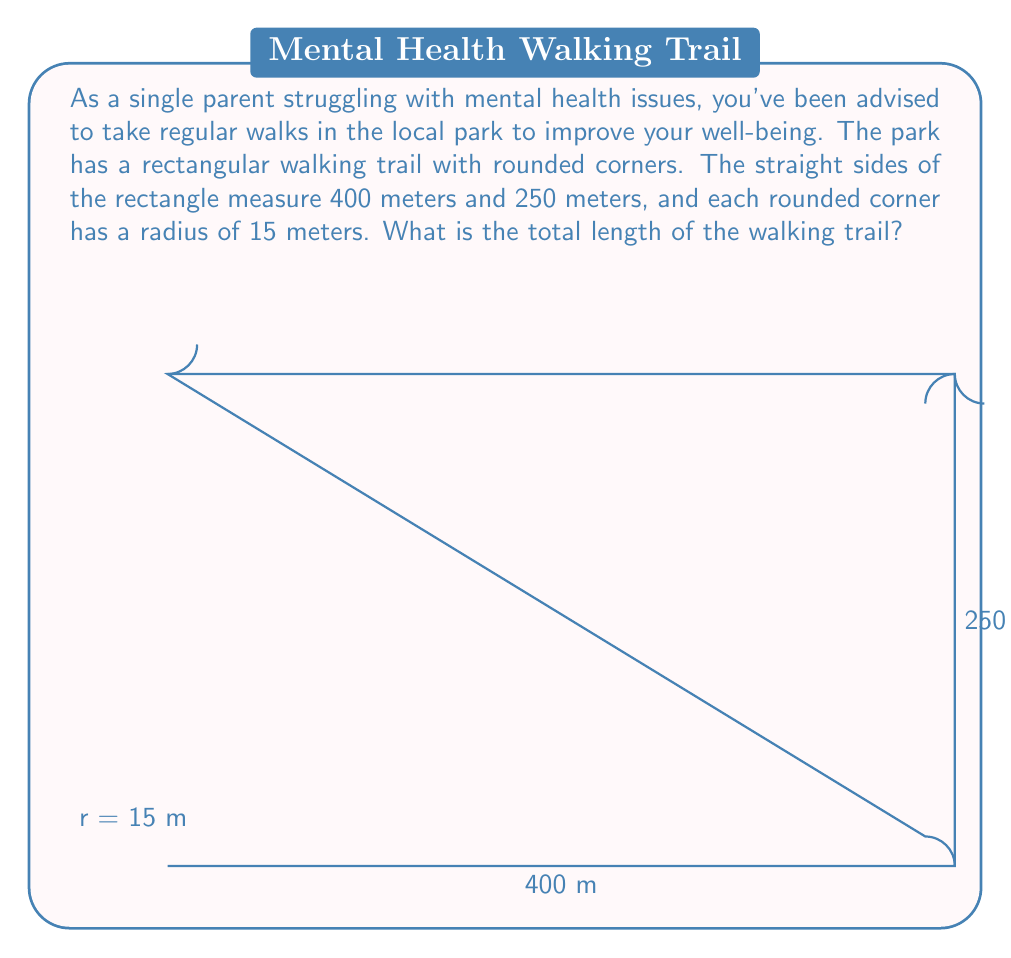Could you help me with this problem? Let's break this problem down step-by-step:

1) First, we need to calculate the perimeter of the rectangle without the rounded corners:
   $$ P_{rectangle} = 2(400 + 250) = 2(650) = 1300 \text{ meters} $$

2) Now, we need to subtract the length of the straight sides that are replaced by the curved corners. There are four corners, each with a radius of 15 meters. The length subtracted for each corner is twice the radius:
   $$ L_{subtracted} = 4 \cdot (2 \cdot 15) = 4 \cdot 30 = 120 \text{ meters} $$

3) The length of the straight parts of the path is now:
   $$ L_{straight} = 1300 - 120 = 1180 \text{ meters} $$

4) For the curved parts, we need to calculate the length of four quarter-circles. The formula for the circumference of a circle is $2\pi r$, so a quarter-circle would be $\frac{1}{2}\pi r$. For all four corners:
   $$ L_{curved} = 4 \cdot \frac{1}{2}\pi r = 4 \cdot \frac{1}{2}\pi \cdot 15 = 30\pi \text{ meters} $$

5) The total length of the path is the sum of the straight parts and the curved parts:
   $$ L_{total} = L_{straight} + L_{curved} = 1180 + 30\pi \text{ meters} $$

6) We can leave the answer in this form, or calculate an approximate value:
   $$ L_{total} \approx 1180 + 30 \cdot 3.14159 \approx 1274.25 \text{ meters} $$
Answer: The total length of the walking trail is $1180 + 30\pi$ meters, or approximately 1274.25 meters. 